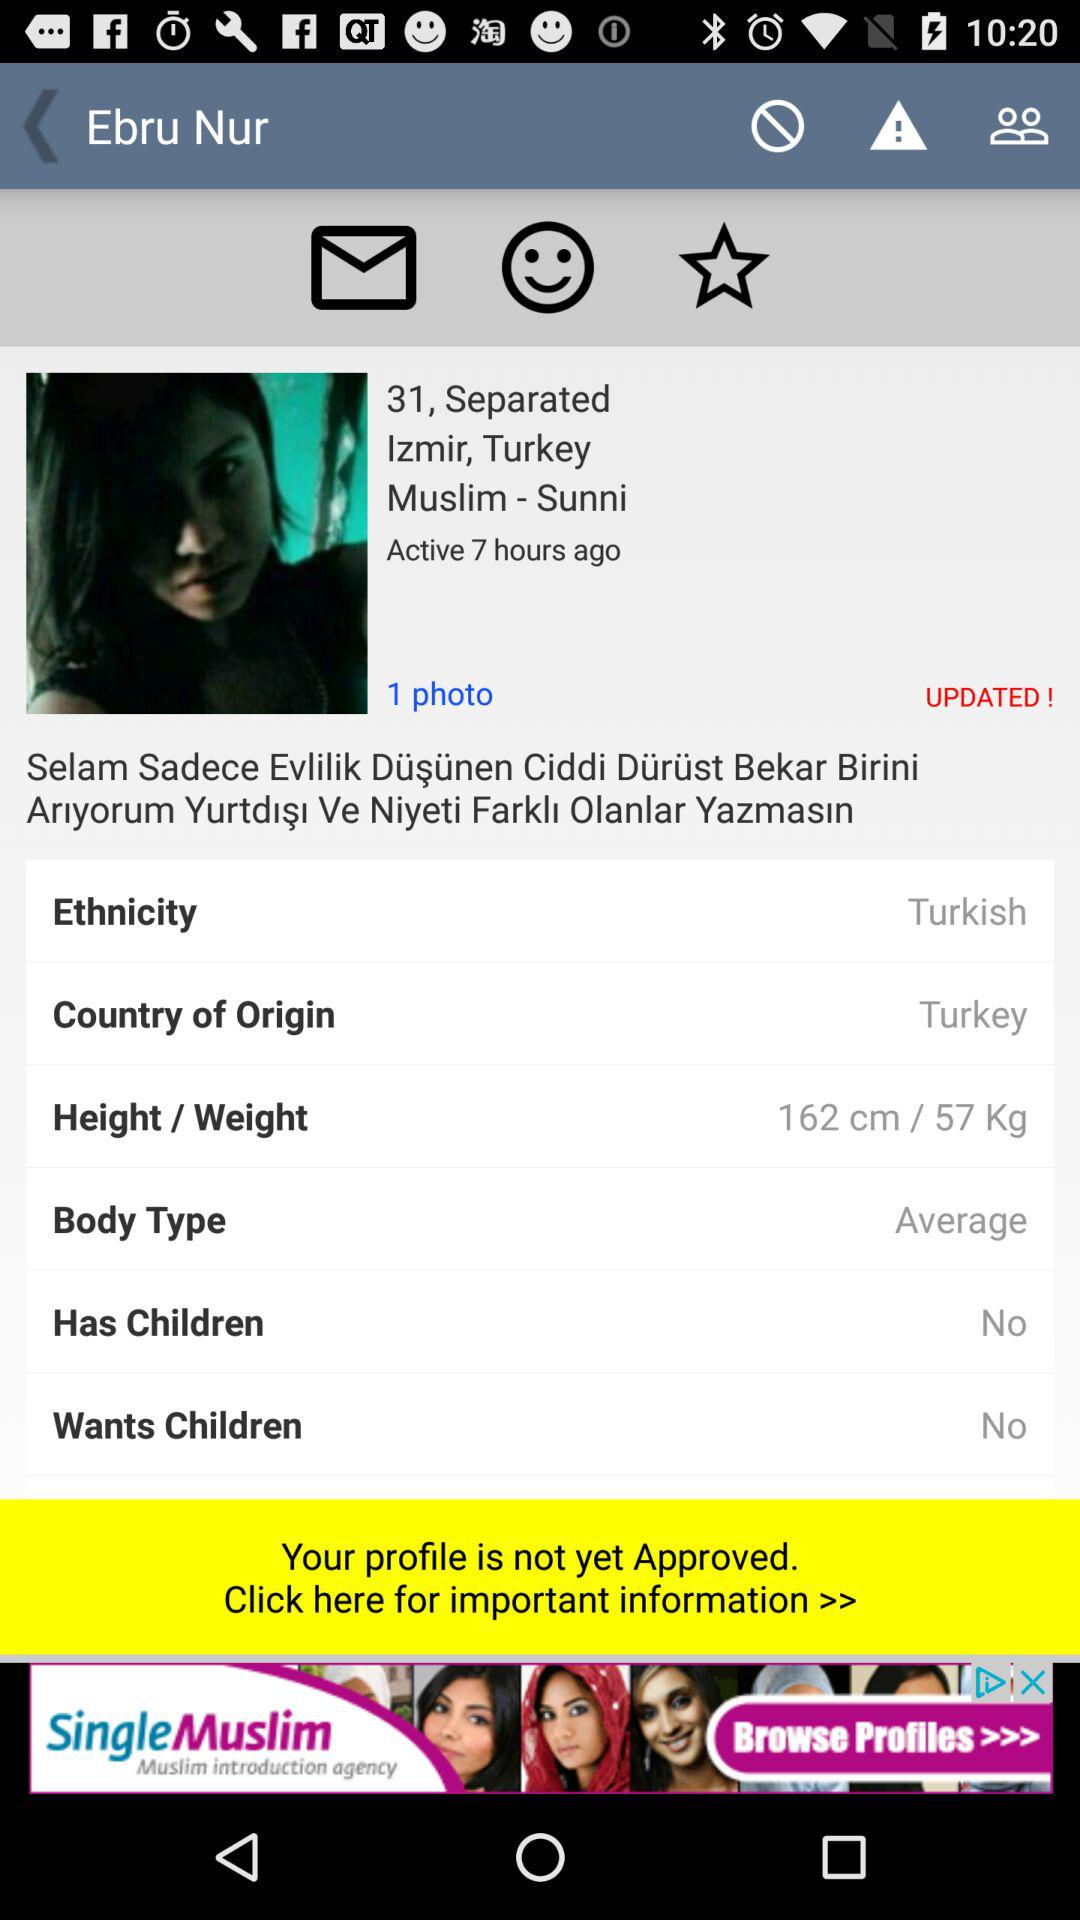What is the weight? The weight is 57 kg. 